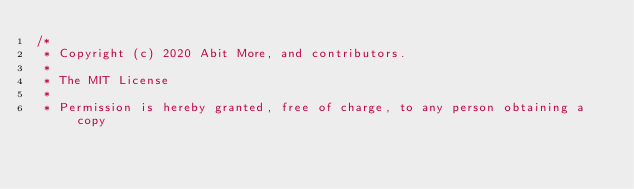<code> <loc_0><loc_0><loc_500><loc_500><_C++_>/*
 * Copyright (c) 2020 Abit More, and contributors.
 *
 * The MIT License
 *
 * Permission is hereby granted, free of charge, to any person obtaining a copy</code> 